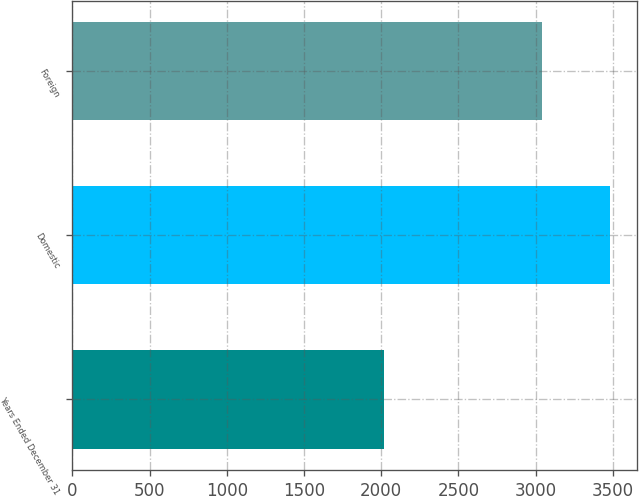<chart> <loc_0><loc_0><loc_500><loc_500><bar_chart><fcel>Years Ended December 31<fcel>Domestic<fcel>Foreign<nl><fcel>2017<fcel>3483<fcel>3038<nl></chart> 